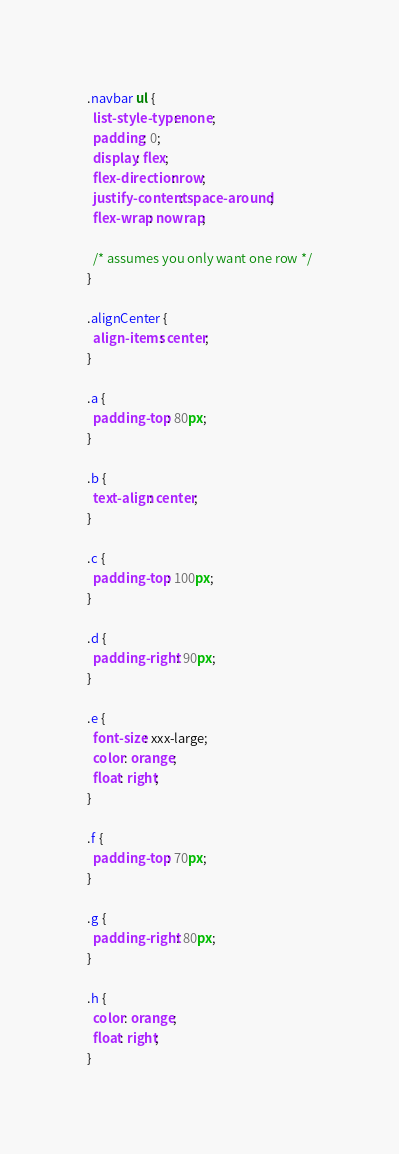<code> <loc_0><loc_0><loc_500><loc_500><_CSS_>.navbar ul {
  list-style-type: none;
  padding: 0;
  display: flex;
  flex-direction: row;
  justify-content: space-around;
  flex-wrap: nowrap;

  /* assumes you only want one row */
}

.alignCenter {
  align-items: center;
}

.a {
  padding-top: 80px;
}

.b {
  text-align: center;
}

.c {
  padding-top: 100px;
}

.d {
  padding-right: 90px;
}

.e {
  font-size: xxx-large;
  color: orange;
  float: right;
}

.f {
  padding-top: 70px;
}

.g {
  padding-right: 80px;
}

.h {
  color: orange;
  float: right;
}
</code> 